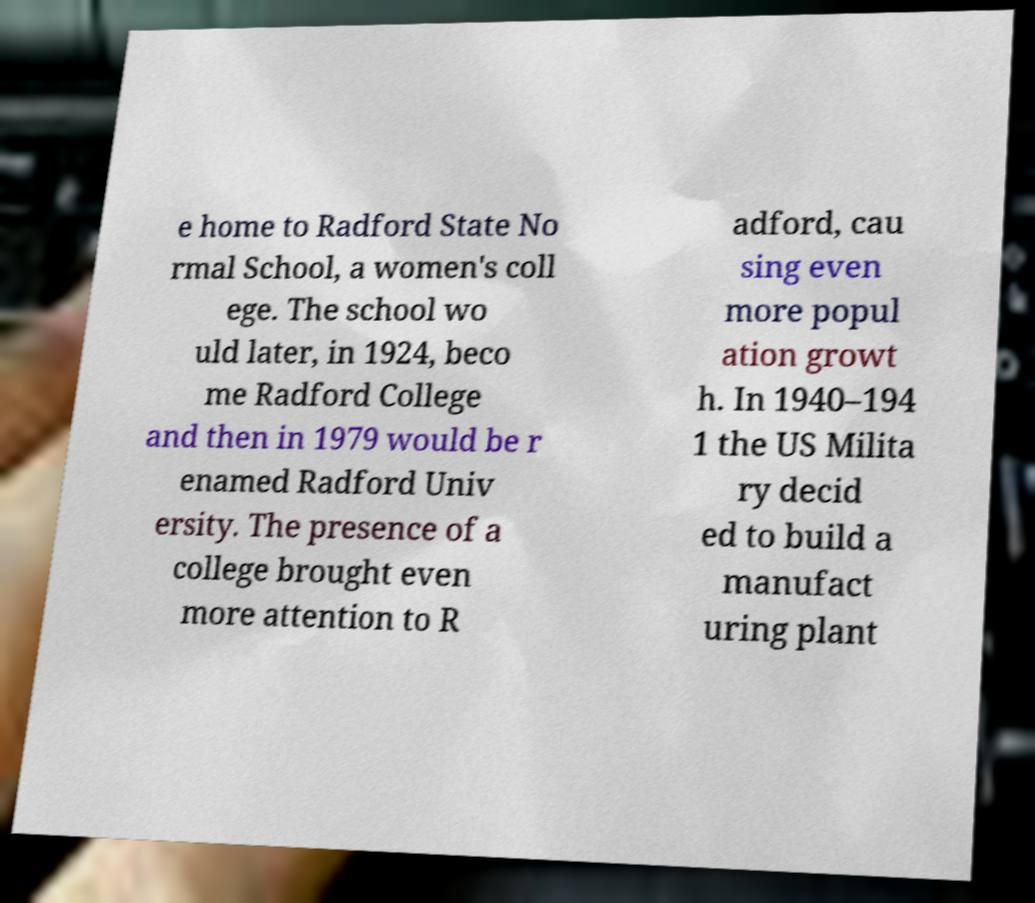Could you extract and type out the text from this image? e home to Radford State No rmal School, a women's coll ege. The school wo uld later, in 1924, beco me Radford College and then in 1979 would be r enamed Radford Univ ersity. The presence of a college brought even more attention to R adford, cau sing even more popul ation growt h. In 1940–194 1 the US Milita ry decid ed to build a manufact uring plant 